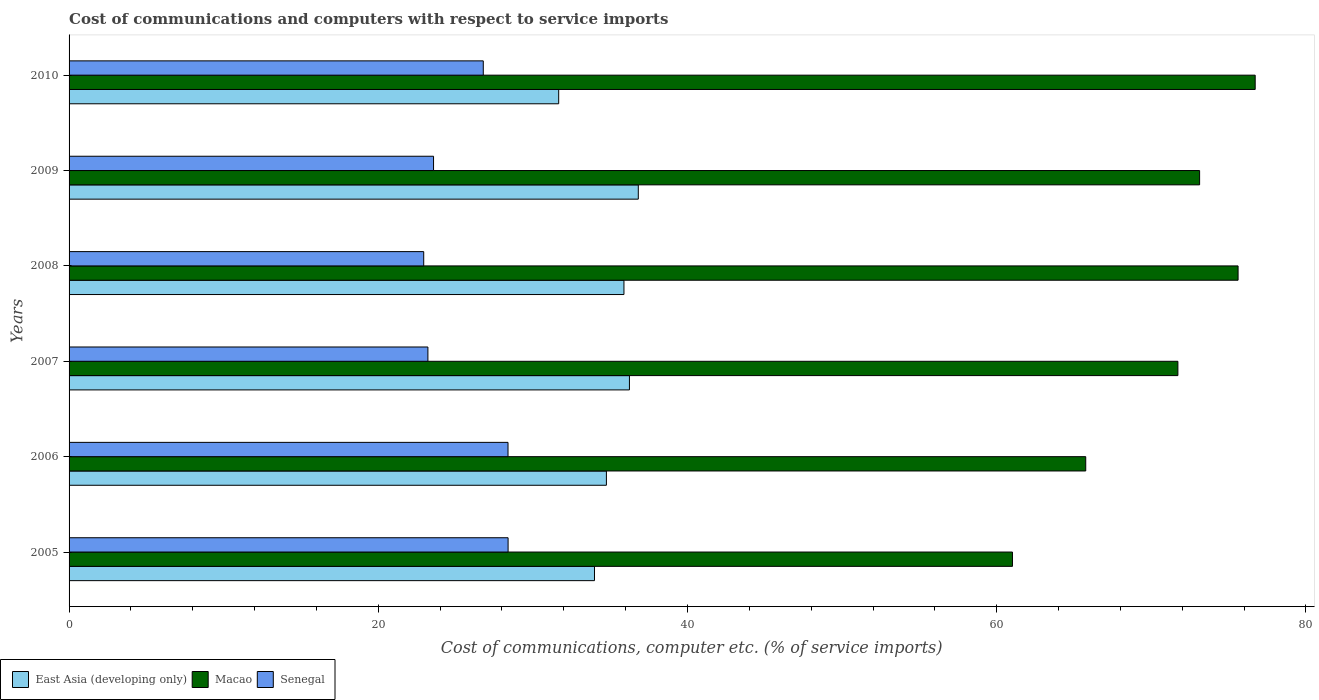How many groups of bars are there?
Offer a terse response. 6. Are the number of bars per tick equal to the number of legend labels?
Your response must be concise. Yes. In how many cases, is the number of bars for a given year not equal to the number of legend labels?
Your answer should be compact. 0. What is the cost of communications and computers in Macao in 2007?
Provide a succinct answer. 71.72. Across all years, what is the maximum cost of communications and computers in East Asia (developing only)?
Offer a very short reply. 36.82. Across all years, what is the minimum cost of communications and computers in Macao?
Your response must be concise. 61.02. What is the total cost of communications and computers in East Asia (developing only) in the graph?
Offer a very short reply. 209.36. What is the difference between the cost of communications and computers in Macao in 2005 and that in 2006?
Your answer should be compact. -4.74. What is the difference between the cost of communications and computers in East Asia (developing only) in 2010 and the cost of communications and computers in Macao in 2009?
Keep it short and to the point. -41.45. What is the average cost of communications and computers in East Asia (developing only) per year?
Provide a short and direct response. 34.89. In the year 2009, what is the difference between the cost of communications and computers in Senegal and cost of communications and computers in East Asia (developing only)?
Your response must be concise. -13.24. What is the ratio of the cost of communications and computers in Macao in 2005 to that in 2007?
Ensure brevity in your answer.  0.85. Is the difference between the cost of communications and computers in Senegal in 2005 and 2006 greater than the difference between the cost of communications and computers in East Asia (developing only) in 2005 and 2006?
Offer a terse response. Yes. What is the difference between the highest and the second highest cost of communications and computers in Senegal?
Offer a terse response. 0. What is the difference between the highest and the lowest cost of communications and computers in Senegal?
Give a very brief answer. 5.46. Is the sum of the cost of communications and computers in East Asia (developing only) in 2005 and 2009 greater than the maximum cost of communications and computers in Senegal across all years?
Make the answer very short. Yes. What does the 1st bar from the top in 2006 represents?
Offer a terse response. Senegal. What does the 2nd bar from the bottom in 2010 represents?
Your answer should be very brief. Macao. Is it the case that in every year, the sum of the cost of communications and computers in Macao and cost of communications and computers in Senegal is greater than the cost of communications and computers in East Asia (developing only)?
Keep it short and to the point. Yes. Are all the bars in the graph horizontal?
Your answer should be compact. Yes. How many years are there in the graph?
Offer a terse response. 6. How are the legend labels stacked?
Make the answer very short. Horizontal. What is the title of the graph?
Provide a succinct answer. Cost of communications and computers with respect to service imports. What is the label or title of the X-axis?
Your answer should be compact. Cost of communications, computer etc. (% of service imports). What is the Cost of communications, computer etc. (% of service imports) in East Asia (developing only) in 2005?
Your answer should be very brief. 33.98. What is the Cost of communications, computer etc. (% of service imports) of Macao in 2005?
Provide a succinct answer. 61.02. What is the Cost of communications, computer etc. (% of service imports) of Senegal in 2005?
Provide a short and direct response. 28.4. What is the Cost of communications, computer etc. (% of service imports) in East Asia (developing only) in 2006?
Your answer should be compact. 34.76. What is the Cost of communications, computer etc. (% of service imports) of Macao in 2006?
Give a very brief answer. 65.76. What is the Cost of communications, computer etc. (% of service imports) in Senegal in 2006?
Offer a very short reply. 28.39. What is the Cost of communications, computer etc. (% of service imports) of East Asia (developing only) in 2007?
Make the answer very short. 36.24. What is the Cost of communications, computer etc. (% of service imports) in Macao in 2007?
Keep it short and to the point. 71.72. What is the Cost of communications, computer etc. (% of service imports) of Senegal in 2007?
Offer a terse response. 23.21. What is the Cost of communications, computer etc. (% of service imports) of East Asia (developing only) in 2008?
Your response must be concise. 35.89. What is the Cost of communications, computer etc. (% of service imports) in Macao in 2008?
Offer a very short reply. 75.61. What is the Cost of communications, computer etc. (% of service imports) of Senegal in 2008?
Offer a very short reply. 22.94. What is the Cost of communications, computer etc. (% of service imports) in East Asia (developing only) in 2009?
Your answer should be compact. 36.82. What is the Cost of communications, computer etc. (% of service imports) of Macao in 2009?
Keep it short and to the point. 73.12. What is the Cost of communications, computer etc. (% of service imports) of Senegal in 2009?
Your response must be concise. 23.57. What is the Cost of communications, computer etc. (% of service imports) of East Asia (developing only) in 2010?
Your answer should be very brief. 31.67. What is the Cost of communications, computer etc. (% of service imports) in Macao in 2010?
Offer a very short reply. 76.72. What is the Cost of communications, computer etc. (% of service imports) in Senegal in 2010?
Your answer should be very brief. 26.79. Across all years, what is the maximum Cost of communications, computer etc. (% of service imports) of East Asia (developing only)?
Your answer should be very brief. 36.82. Across all years, what is the maximum Cost of communications, computer etc. (% of service imports) in Macao?
Provide a short and direct response. 76.72. Across all years, what is the maximum Cost of communications, computer etc. (% of service imports) of Senegal?
Ensure brevity in your answer.  28.4. Across all years, what is the minimum Cost of communications, computer etc. (% of service imports) of East Asia (developing only)?
Your response must be concise. 31.67. Across all years, what is the minimum Cost of communications, computer etc. (% of service imports) in Macao?
Provide a short and direct response. 61.02. Across all years, what is the minimum Cost of communications, computer etc. (% of service imports) of Senegal?
Your response must be concise. 22.94. What is the total Cost of communications, computer etc. (% of service imports) in East Asia (developing only) in the graph?
Ensure brevity in your answer.  209.36. What is the total Cost of communications, computer etc. (% of service imports) in Macao in the graph?
Provide a short and direct response. 423.95. What is the total Cost of communications, computer etc. (% of service imports) in Senegal in the graph?
Keep it short and to the point. 153.3. What is the difference between the Cost of communications, computer etc. (% of service imports) in East Asia (developing only) in 2005 and that in 2006?
Keep it short and to the point. -0.77. What is the difference between the Cost of communications, computer etc. (% of service imports) of Macao in 2005 and that in 2006?
Your answer should be compact. -4.74. What is the difference between the Cost of communications, computer etc. (% of service imports) in Senegal in 2005 and that in 2006?
Keep it short and to the point. 0. What is the difference between the Cost of communications, computer etc. (% of service imports) of East Asia (developing only) in 2005 and that in 2007?
Provide a succinct answer. -2.26. What is the difference between the Cost of communications, computer etc. (% of service imports) of Macao in 2005 and that in 2007?
Your answer should be compact. -10.7. What is the difference between the Cost of communications, computer etc. (% of service imports) in Senegal in 2005 and that in 2007?
Make the answer very short. 5.19. What is the difference between the Cost of communications, computer etc. (% of service imports) of East Asia (developing only) in 2005 and that in 2008?
Give a very brief answer. -1.91. What is the difference between the Cost of communications, computer etc. (% of service imports) of Macao in 2005 and that in 2008?
Give a very brief answer. -14.59. What is the difference between the Cost of communications, computer etc. (% of service imports) of Senegal in 2005 and that in 2008?
Provide a succinct answer. 5.46. What is the difference between the Cost of communications, computer etc. (% of service imports) in East Asia (developing only) in 2005 and that in 2009?
Your answer should be compact. -2.83. What is the difference between the Cost of communications, computer etc. (% of service imports) of Macao in 2005 and that in 2009?
Keep it short and to the point. -12.1. What is the difference between the Cost of communications, computer etc. (% of service imports) in Senegal in 2005 and that in 2009?
Give a very brief answer. 4.82. What is the difference between the Cost of communications, computer etc. (% of service imports) of East Asia (developing only) in 2005 and that in 2010?
Offer a terse response. 2.32. What is the difference between the Cost of communications, computer etc. (% of service imports) of Macao in 2005 and that in 2010?
Ensure brevity in your answer.  -15.7. What is the difference between the Cost of communications, computer etc. (% of service imports) of Senegal in 2005 and that in 2010?
Keep it short and to the point. 1.6. What is the difference between the Cost of communications, computer etc. (% of service imports) of East Asia (developing only) in 2006 and that in 2007?
Your response must be concise. -1.49. What is the difference between the Cost of communications, computer etc. (% of service imports) in Macao in 2006 and that in 2007?
Give a very brief answer. -5.96. What is the difference between the Cost of communications, computer etc. (% of service imports) of Senegal in 2006 and that in 2007?
Your response must be concise. 5.18. What is the difference between the Cost of communications, computer etc. (% of service imports) in East Asia (developing only) in 2006 and that in 2008?
Offer a very short reply. -1.14. What is the difference between the Cost of communications, computer etc. (% of service imports) in Macao in 2006 and that in 2008?
Provide a succinct answer. -9.85. What is the difference between the Cost of communications, computer etc. (% of service imports) in Senegal in 2006 and that in 2008?
Offer a very short reply. 5.45. What is the difference between the Cost of communications, computer etc. (% of service imports) in East Asia (developing only) in 2006 and that in 2009?
Provide a succinct answer. -2.06. What is the difference between the Cost of communications, computer etc. (% of service imports) in Macao in 2006 and that in 2009?
Keep it short and to the point. -7.37. What is the difference between the Cost of communications, computer etc. (% of service imports) of Senegal in 2006 and that in 2009?
Ensure brevity in your answer.  4.82. What is the difference between the Cost of communications, computer etc. (% of service imports) in East Asia (developing only) in 2006 and that in 2010?
Offer a terse response. 3.09. What is the difference between the Cost of communications, computer etc. (% of service imports) in Macao in 2006 and that in 2010?
Provide a succinct answer. -10.96. What is the difference between the Cost of communications, computer etc. (% of service imports) in Senegal in 2006 and that in 2010?
Offer a terse response. 1.6. What is the difference between the Cost of communications, computer etc. (% of service imports) in East Asia (developing only) in 2007 and that in 2008?
Your answer should be very brief. 0.35. What is the difference between the Cost of communications, computer etc. (% of service imports) of Macao in 2007 and that in 2008?
Provide a succinct answer. -3.89. What is the difference between the Cost of communications, computer etc. (% of service imports) of Senegal in 2007 and that in 2008?
Your answer should be compact. 0.27. What is the difference between the Cost of communications, computer etc. (% of service imports) of East Asia (developing only) in 2007 and that in 2009?
Your answer should be very brief. -0.57. What is the difference between the Cost of communications, computer etc. (% of service imports) of Macao in 2007 and that in 2009?
Make the answer very short. -1.4. What is the difference between the Cost of communications, computer etc. (% of service imports) in Senegal in 2007 and that in 2009?
Give a very brief answer. -0.36. What is the difference between the Cost of communications, computer etc. (% of service imports) of East Asia (developing only) in 2007 and that in 2010?
Your answer should be compact. 4.58. What is the difference between the Cost of communications, computer etc. (% of service imports) of Macao in 2007 and that in 2010?
Provide a short and direct response. -5. What is the difference between the Cost of communications, computer etc. (% of service imports) in Senegal in 2007 and that in 2010?
Offer a very short reply. -3.58. What is the difference between the Cost of communications, computer etc. (% of service imports) in East Asia (developing only) in 2008 and that in 2009?
Your answer should be very brief. -0.93. What is the difference between the Cost of communications, computer etc. (% of service imports) of Macao in 2008 and that in 2009?
Provide a succinct answer. 2.49. What is the difference between the Cost of communications, computer etc. (% of service imports) of Senegal in 2008 and that in 2009?
Your answer should be very brief. -0.64. What is the difference between the Cost of communications, computer etc. (% of service imports) in East Asia (developing only) in 2008 and that in 2010?
Provide a succinct answer. 4.22. What is the difference between the Cost of communications, computer etc. (% of service imports) in Macao in 2008 and that in 2010?
Keep it short and to the point. -1.11. What is the difference between the Cost of communications, computer etc. (% of service imports) in Senegal in 2008 and that in 2010?
Offer a very short reply. -3.85. What is the difference between the Cost of communications, computer etc. (% of service imports) of East Asia (developing only) in 2009 and that in 2010?
Provide a short and direct response. 5.15. What is the difference between the Cost of communications, computer etc. (% of service imports) of Macao in 2009 and that in 2010?
Keep it short and to the point. -3.6. What is the difference between the Cost of communications, computer etc. (% of service imports) in Senegal in 2009 and that in 2010?
Offer a terse response. -3.22. What is the difference between the Cost of communications, computer etc. (% of service imports) of East Asia (developing only) in 2005 and the Cost of communications, computer etc. (% of service imports) of Macao in 2006?
Ensure brevity in your answer.  -31.77. What is the difference between the Cost of communications, computer etc. (% of service imports) of East Asia (developing only) in 2005 and the Cost of communications, computer etc. (% of service imports) of Senegal in 2006?
Provide a short and direct response. 5.59. What is the difference between the Cost of communications, computer etc. (% of service imports) in Macao in 2005 and the Cost of communications, computer etc. (% of service imports) in Senegal in 2006?
Provide a short and direct response. 32.63. What is the difference between the Cost of communications, computer etc. (% of service imports) of East Asia (developing only) in 2005 and the Cost of communications, computer etc. (% of service imports) of Macao in 2007?
Offer a very short reply. -37.73. What is the difference between the Cost of communications, computer etc. (% of service imports) of East Asia (developing only) in 2005 and the Cost of communications, computer etc. (% of service imports) of Senegal in 2007?
Give a very brief answer. 10.77. What is the difference between the Cost of communications, computer etc. (% of service imports) of Macao in 2005 and the Cost of communications, computer etc. (% of service imports) of Senegal in 2007?
Your answer should be compact. 37.81. What is the difference between the Cost of communications, computer etc. (% of service imports) of East Asia (developing only) in 2005 and the Cost of communications, computer etc. (% of service imports) of Macao in 2008?
Your answer should be compact. -41.63. What is the difference between the Cost of communications, computer etc. (% of service imports) of East Asia (developing only) in 2005 and the Cost of communications, computer etc. (% of service imports) of Senegal in 2008?
Your answer should be compact. 11.05. What is the difference between the Cost of communications, computer etc. (% of service imports) in Macao in 2005 and the Cost of communications, computer etc. (% of service imports) in Senegal in 2008?
Offer a very short reply. 38.08. What is the difference between the Cost of communications, computer etc. (% of service imports) in East Asia (developing only) in 2005 and the Cost of communications, computer etc. (% of service imports) in Macao in 2009?
Offer a very short reply. -39.14. What is the difference between the Cost of communications, computer etc. (% of service imports) of East Asia (developing only) in 2005 and the Cost of communications, computer etc. (% of service imports) of Senegal in 2009?
Your response must be concise. 10.41. What is the difference between the Cost of communications, computer etc. (% of service imports) of Macao in 2005 and the Cost of communications, computer etc. (% of service imports) of Senegal in 2009?
Keep it short and to the point. 37.44. What is the difference between the Cost of communications, computer etc. (% of service imports) in East Asia (developing only) in 2005 and the Cost of communications, computer etc. (% of service imports) in Macao in 2010?
Provide a succinct answer. -42.73. What is the difference between the Cost of communications, computer etc. (% of service imports) of East Asia (developing only) in 2005 and the Cost of communications, computer etc. (% of service imports) of Senegal in 2010?
Make the answer very short. 7.19. What is the difference between the Cost of communications, computer etc. (% of service imports) in Macao in 2005 and the Cost of communications, computer etc. (% of service imports) in Senegal in 2010?
Your answer should be very brief. 34.23. What is the difference between the Cost of communications, computer etc. (% of service imports) in East Asia (developing only) in 2006 and the Cost of communications, computer etc. (% of service imports) in Macao in 2007?
Your response must be concise. -36.96. What is the difference between the Cost of communications, computer etc. (% of service imports) in East Asia (developing only) in 2006 and the Cost of communications, computer etc. (% of service imports) in Senegal in 2007?
Keep it short and to the point. 11.55. What is the difference between the Cost of communications, computer etc. (% of service imports) in Macao in 2006 and the Cost of communications, computer etc. (% of service imports) in Senegal in 2007?
Make the answer very short. 42.55. What is the difference between the Cost of communications, computer etc. (% of service imports) in East Asia (developing only) in 2006 and the Cost of communications, computer etc. (% of service imports) in Macao in 2008?
Ensure brevity in your answer.  -40.86. What is the difference between the Cost of communications, computer etc. (% of service imports) in East Asia (developing only) in 2006 and the Cost of communications, computer etc. (% of service imports) in Senegal in 2008?
Offer a terse response. 11.82. What is the difference between the Cost of communications, computer etc. (% of service imports) of Macao in 2006 and the Cost of communications, computer etc. (% of service imports) of Senegal in 2008?
Offer a terse response. 42.82. What is the difference between the Cost of communications, computer etc. (% of service imports) of East Asia (developing only) in 2006 and the Cost of communications, computer etc. (% of service imports) of Macao in 2009?
Keep it short and to the point. -38.37. What is the difference between the Cost of communications, computer etc. (% of service imports) in East Asia (developing only) in 2006 and the Cost of communications, computer etc. (% of service imports) in Senegal in 2009?
Offer a very short reply. 11.18. What is the difference between the Cost of communications, computer etc. (% of service imports) in Macao in 2006 and the Cost of communications, computer etc. (% of service imports) in Senegal in 2009?
Ensure brevity in your answer.  42.18. What is the difference between the Cost of communications, computer etc. (% of service imports) of East Asia (developing only) in 2006 and the Cost of communications, computer etc. (% of service imports) of Macao in 2010?
Ensure brevity in your answer.  -41.96. What is the difference between the Cost of communications, computer etc. (% of service imports) of East Asia (developing only) in 2006 and the Cost of communications, computer etc. (% of service imports) of Senegal in 2010?
Offer a terse response. 7.96. What is the difference between the Cost of communications, computer etc. (% of service imports) in Macao in 2006 and the Cost of communications, computer etc. (% of service imports) in Senegal in 2010?
Keep it short and to the point. 38.97. What is the difference between the Cost of communications, computer etc. (% of service imports) in East Asia (developing only) in 2007 and the Cost of communications, computer etc. (% of service imports) in Macao in 2008?
Keep it short and to the point. -39.37. What is the difference between the Cost of communications, computer etc. (% of service imports) in East Asia (developing only) in 2007 and the Cost of communications, computer etc. (% of service imports) in Senegal in 2008?
Your answer should be compact. 13.31. What is the difference between the Cost of communications, computer etc. (% of service imports) in Macao in 2007 and the Cost of communications, computer etc. (% of service imports) in Senegal in 2008?
Provide a succinct answer. 48.78. What is the difference between the Cost of communications, computer etc. (% of service imports) of East Asia (developing only) in 2007 and the Cost of communications, computer etc. (% of service imports) of Macao in 2009?
Give a very brief answer. -36.88. What is the difference between the Cost of communications, computer etc. (% of service imports) of East Asia (developing only) in 2007 and the Cost of communications, computer etc. (% of service imports) of Senegal in 2009?
Provide a succinct answer. 12.67. What is the difference between the Cost of communications, computer etc. (% of service imports) in Macao in 2007 and the Cost of communications, computer etc. (% of service imports) in Senegal in 2009?
Ensure brevity in your answer.  48.14. What is the difference between the Cost of communications, computer etc. (% of service imports) in East Asia (developing only) in 2007 and the Cost of communications, computer etc. (% of service imports) in Macao in 2010?
Keep it short and to the point. -40.47. What is the difference between the Cost of communications, computer etc. (% of service imports) in East Asia (developing only) in 2007 and the Cost of communications, computer etc. (% of service imports) in Senegal in 2010?
Ensure brevity in your answer.  9.45. What is the difference between the Cost of communications, computer etc. (% of service imports) of Macao in 2007 and the Cost of communications, computer etc. (% of service imports) of Senegal in 2010?
Ensure brevity in your answer.  44.93. What is the difference between the Cost of communications, computer etc. (% of service imports) of East Asia (developing only) in 2008 and the Cost of communications, computer etc. (% of service imports) of Macao in 2009?
Provide a succinct answer. -37.23. What is the difference between the Cost of communications, computer etc. (% of service imports) of East Asia (developing only) in 2008 and the Cost of communications, computer etc. (% of service imports) of Senegal in 2009?
Your response must be concise. 12.32. What is the difference between the Cost of communications, computer etc. (% of service imports) in Macao in 2008 and the Cost of communications, computer etc. (% of service imports) in Senegal in 2009?
Your answer should be very brief. 52.04. What is the difference between the Cost of communications, computer etc. (% of service imports) of East Asia (developing only) in 2008 and the Cost of communications, computer etc. (% of service imports) of Macao in 2010?
Provide a succinct answer. -40.83. What is the difference between the Cost of communications, computer etc. (% of service imports) in East Asia (developing only) in 2008 and the Cost of communications, computer etc. (% of service imports) in Senegal in 2010?
Offer a very short reply. 9.1. What is the difference between the Cost of communications, computer etc. (% of service imports) of Macao in 2008 and the Cost of communications, computer etc. (% of service imports) of Senegal in 2010?
Offer a very short reply. 48.82. What is the difference between the Cost of communications, computer etc. (% of service imports) in East Asia (developing only) in 2009 and the Cost of communications, computer etc. (% of service imports) in Macao in 2010?
Your answer should be compact. -39.9. What is the difference between the Cost of communications, computer etc. (% of service imports) in East Asia (developing only) in 2009 and the Cost of communications, computer etc. (% of service imports) in Senegal in 2010?
Offer a terse response. 10.03. What is the difference between the Cost of communications, computer etc. (% of service imports) of Macao in 2009 and the Cost of communications, computer etc. (% of service imports) of Senegal in 2010?
Provide a short and direct response. 46.33. What is the average Cost of communications, computer etc. (% of service imports) in East Asia (developing only) per year?
Make the answer very short. 34.89. What is the average Cost of communications, computer etc. (% of service imports) in Macao per year?
Keep it short and to the point. 70.66. What is the average Cost of communications, computer etc. (% of service imports) in Senegal per year?
Make the answer very short. 25.55. In the year 2005, what is the difference between the Cost of communications, computer etc. (% of service imports) in East Asia (developing only) and Cost of communications, computer etc. (% of service imports) in Macao?
Give a very brief answer. -27.04. In the year 2005, what is the difference between the Cost of communications, computer etc. (% of service imports) of East Asia (developing only) and Cost of communications, computer etc. (% of service imports) of Senegal?
Your answer should be very brief. 5.59. In the year 2005, what is the difference between the Cost of communications, computer etc. (% of service imports) in Macao and Cost of communications, computer etc. (% of service imports) in Senegal?
Keep it short and to the point. 32.62. In the year 2006, what is the difference between the Cost of communications, computer etc. (% of service imports) in East Asia (developing only) and Cost of communications, computer etc. (% of service imports) in Macao?
Offer a very short reply. -31. In the year 2006, what is the difference between the Cost of communications, computer etc. (% of service imports) of East Asia (developing only) and Cost of communications, computer etc. (% of service imports) of Senegal?
Your answer should be compact. 6.36. In the year 2006, what is the difference between the Cost of communications, computer etc. (% of service imports) of Macao and Cost of communications, computer etc. (% of service imports) of Senegal?
Your response must be concise. 37.37. In the year 2007, what is the difference between the Cost of communications, computer etc. (% of service imports) of East Asia (developing only) and Cost of communications, computer etc. (% of service imports) of Macao?
Provide a short and direct response. -35.47. In the year 2007, what is the difference between the Cost of communications, computer etc. (% of service imports) of East Asia (developing only) and Cost of communications, computer etc. (% of service imports) of Senegal?
Make the answer very short. 13.04. In the year 2007, what is the difference between the Cost of communications, computer etc. (% of service imports) of Macao and Cost of communications, computer etc. (% of service imports) of Senegal?
Give a very brief answer. 48.51. In the year 2008, what is the difference between the Cost of communications, computer etc. (% of service imports) in East Asia (developing only) and Cost of communications, computer etc. (% of service imports) in Macao?
Your answer should be compact. -39.72. In the year 2008, what is the difference between the Cost of communications, computer etc. (% of service imports) of East Asia (developing only) and Cost of communications, computer etc. (% of service imports) of Senegal?
Provide a succinct answer. 12.95. In the year 2008, what is the difference between the Cost of communications, computer etc. (% of service imports) of Macao and Cost of communications, computer etc. (% of service imports) of Senegal?
Give a very brief answer. 52.67. In the year 2009, what is the difference between the Cost of communications, computer etc. (% of service imports) of East Asia (developing only) and Cost of communications, computer etc. (% of service imports) of Macao?
Ensure brevity in your answer.  -36.31. In the year 2009, what is the difference between the Cost of communications, computer etc. (% of service imports) in East Asia (developing only) and Cost of communications, computer etc. (% of service imports) in Senegal?
Give a very brief answer. 13.24. In the year 2009, what is the difference between the Cost of communications, computer etc. (% of service imports) in Macao and Cost of communications, computer etc. (% of service imports) in Senegal?
Give a very brief answer. 49.55. In the year 2010, what is the difference between the Cost of communications, computer etc. (% of service imports) of East Asia (developing only) and Cost of communications, computer etc. (% of service imports) of Macao?
Offer a terse response. -45.05. In the year 2010, what is the difference between the Cost of communications, computer etc. (% of service imports) in East Asia (developing only) and Cost of communications, computer etc. (% of service imports) in Senegal?
Make the answer very short. 4.88. In the year 2010, what is the difference between the Cost of communications, computer etc. (% of service imports) in Macao and Cost of communications, computer etc. (% of service imports) in Senegal?
Give a very brief answer. 49.93. What is the ratio of the Cost of communications, computer etc. (% of service imports) of East Asia (developing only) in 2005 to that in 2006?
Keep it short and to the point. 0.98. What is the ratio of the Cost of communications, computer etc. (% of service imports) in Macao in 2005 to that in 2006?
Make the answer very short. 0.93. What is the ratio of the Cost of communications, computer etc. (% of service imports) in East Asia (developing only) in 2005 to that in 2007?
Ensure brevity in your answer.  0.94. What is the ratio of the Cost of communications, computer etc. (% of service imports) of Macao in 2005 to that in 2007?
Offer a very short reply. 0.85. What is the ratio of the Cost of communications, computer etc. (% of service imports) in Senegal in 2005 to that in 2007?
Make the answer very short. 1.22. What is the ratio of the Cost of communications, computer etc. (% of service imports) in East Asia (developing only) in 2005 to that in 2008?
Make the answer very short. 0.95. What is the ratio of the Cost of communications, computer etc. (% of service imports) in Macao in 2005 to that in 2008?
Your answer should be very brief. 0.81. What is the ratio of the Cost of communications, computer etc. (% of service imports) in Senegal in 2005 to that in 2008?
Give a very brief answer. 1.24. What is the ratio of the Cost of communications, computer etc. (% of service imports) of East Asia (developing only) in 2005 to that in 2009?
Keep it short and to the point. 0.92. What is the ratio of the Cost of communications, computer etc. (% of service imports) in Macao in 2005 to that in 2009?
Make the answer very short. 0.83. What is the ratio of the Cost of communications, computer etc. (% of service imports) of Senegal in 2005 to that in 2009?
Ensure brevity in your answer.  1.2. What is the ratio of the Cost of communications, computer etc. (% of service imports) in East Asia (developing only) in 2005 to that in 2010?
Provide a succinct answer. 1.07. What is the ratio of the Cost of communications, computer etc. (% of service imports) of Macao in 2005 to that in 2010?
Make the answer very short. 0.8. What is the ratio of the Cost of communications, computer etc. (% of service imports) of Senegal in 2005 to that in 2010?
Your answer should be very brief. 1.06. What is the ratio of the Cost of communications, computer etc. (% of service imports) in East Asia (developing only) in 2006 to that in 2007?
Provide a short and direct response. 0.96. What is the ratio of the Cost of communications, computer etc. (% of service imports) of Macao in 2006 to that in 2007?
Ensure brevity in your answer.  0.92. What is the ratio of the Cost of communications, computer etc. (% of service imports) of Senegal in 2006 to that in 2007?
Provide a short and direct response. 1.22. What is the ratio of the Cost of communications, computer etc. (% of service imports) in East Asia (developing only) in 2006 to that in 2008?
Your response must be concise. 0.97. What is the ratio of the Cost of communications, computer etc. (% of service imports) in Macao in 2006 to that in 2008?
Give a very brief answer. 0.87. What is the ratio of the Cost of communications, computer etc. (% of service imports) in Senegal in 2006 to that in 2008?
Keep it short and to the point. 1.24. What is the ratio of the Cost of communications, computer etc. (% of service imports) in East Asia (developing only) in 2006 to that in 2009?
Your answer should be compact. 0.94. What is the ratio of the Cost of communications, computer etc. (% of service imports) of Macao in 2006 to that in 2009?
Your answer should be compact. 0.9. What is the ratio of the Cost of communications, computer etc. (% of service imports) of Senegal in 2006 to that in 2009?
Ensure brevity in your answer.  1.2. What is the ratio of the Cost of communications, computer etc. (% of service imports) of East Asia (developing only) in 2006 to that in 2010?
Your response must be concise. 1.1. What is the ratio of the Cost of communications, computer etc. (% of service imports) in Senegal in 2006 to that in 2010?
Keep it short and to the point. 1.06. What is the ratio of the Cost of communications, computer etc. (% of service imports) of East Asia (developing only) in 2007 to that in 2008?
Provide a short and direct response. 1.01. What is the ratio of the Cost of communications, computer etc. (% of service imports) in Macao in 2007 to that in 2008?
Provide a short and direct response. 0.95. What is the ratio of the Cost of communications, computer etc. (% of service imports) in Senegal in 2007 to that in 2008?
Provide a short and direct response. 1.01. What is the ratio of the Cost of communications, computer etc. (% of service imports) in East Asia (developing only) in 2007 to that in 2009?
Keep it short and to the point. 0.98. What is the ratio of the Cost of communications, computer etc. (% of service imports) of Macao in 2007 to that in 2009?
Give a very brief answer. 0.98. What is the ratio of the Cost of communications, computer etc. (% of service imports) of Senegal in 2007 to that in 2009?
Provide a succinct answer. 0.98. What is the ratio of the Cost of communications, computer etc. (% of service imports) of East Asia (developing only) in 2007 to that in 2010?
Provide a short and direct response. 1.14. What is the ratio of the Cost of communications, computer etc. (% of service imports) of Macao in 2007 to that in 2010?
Make the answer very short. 0.93. What is the ratio of the Cost of communications, computer etc. (% of service imports) in Senegal in 2007 to that in 2010?
Your answer should be compact. 0.87. What is the ratio of the Cost of communications, computer etc. (% of service imports) of East Asia (developing only) in 2008 to that in 2009?
Your answer should be compact. 0.97. What is the ratio of the Cost of communications, computer etc. (% of service imports) in Macao in 2008 to that in 2009?
Your answer should be very brief. 1.03. What is the ratio of the Cost of communications, computer etc. (% of service imports) of Senegal in 2008 to that in 2009?
Provide a short and direct response. 0.97. What is the ratio of the Cost of communications, computer etc. (% of service imports) in East Asia (developing only) in 2008 to that in 2010?
Offer a terse response. 1.13. What is the ratio of the Cost of communications, computer etc. (% of service imports) of Macao in 2008 to that in 2010?
Offer a terse response. 0.99. What is the ratio of the Cost of communications, computer etc. (% of service imports) of Senegal in 2008 to that in 2010?
Provide a succinct answer. 0.86. What is the ratio of the Cost of communications, computer etc. (% of service imports) in East Asia (developing only) in 2009 to that in 2010?
Your answer should be very brief. 1.16. What is the ratio of the Cost of communications, computer etc. (% of service imports) of Macao in 2009 to that in 2010?
Your answer should be very brief. 0.95. What is the ratio of the Cost of communications, computer etc. (% of service imports) in Senegal in 2009 to that in 2010?
Keep it short and to the point. 0.88. What is the difference between the highest and the second highest Cost of communications, computer etc. (% of service imports) of East Asia (developing only)?
Offer a very short reply. 0.57. What is the difference between the highest and the second highest Cost of communications, computer etc. (% of service imports) of Macao?
Give a very brief answer. 1.11. What is the difference between the highest and the second highest Cost of communications, computer etc. (% of service imports) of Senegal?
Offer a very short reply. 0. What is the difference between the highest and the lowest Cost of communications, computer etc. (% of service imports) of East Asia (developing only)?
Give a very brief answer. 5.15. What is the difference between the highest and the lowest Cost of communications, computer etc. (% of service imports) in Macao?
Make the answer very short. 15.7. What is the difference between the highest and the lowest Cost of communications, computer etc. (% of service imports) of Senegal?
Offer a very short reply. 5.46. 